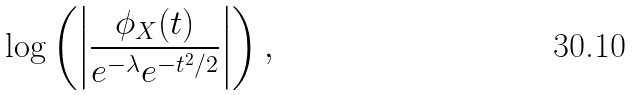Convert formula to latex. <formula><loc_0><loc_0><loc_500><loc_500>\log \left ( \left | \frac { \phi _ { X } ( t ) } { e ^ { - \lambda } e ^ { - t ^ { 2 } / 2 } } \right | \right ) ,</formula> 